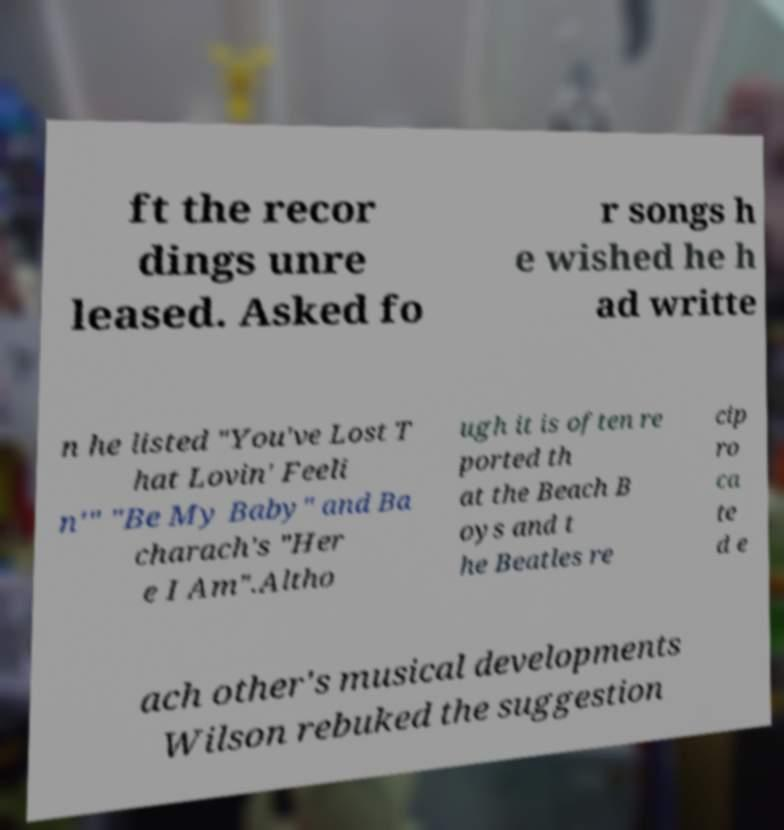Please read and relay the text visible in this image. What does it say? ft the recor dings unre leased. Asked fo r songs h e wished he h ad writte n he listed "You've Lost T hat Lovin' Feeli n'" "Be My Baby" and Ba charach's "Her e I Am".Altho ugh it is often re ported th at the Beach B oys and t he Beatles re cip ro ca te d e ach other's musical developments Wilson rebuked the suggestion 